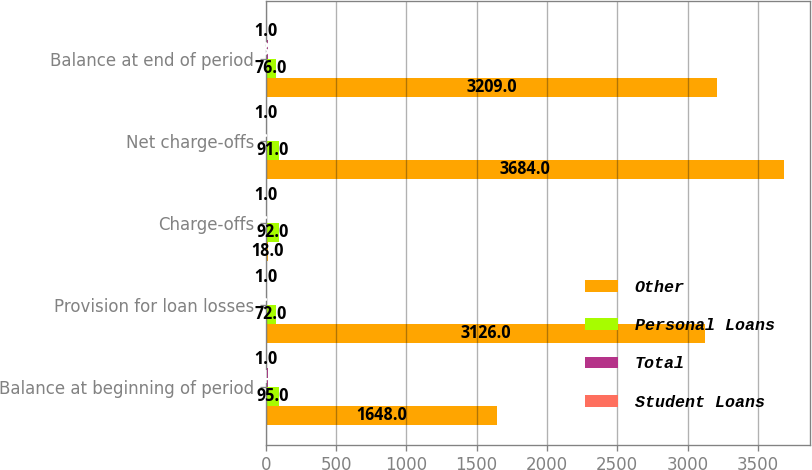<chart> <loc_0><loc_0><loc_500><loc_500><stacked_bar_chart><ecel><fcel>Balance at beginning of period<fcel>Provision for loan losses<fcel>Charge-offs<fcel>Net charge-offs<fcel>Balance at end of period<nl><fcel>Other<fcel>1648<fcel>3126<fcel>18<fcel>3684<fcel>3209<nl><fcel>Personal Loans<fcel>95<fcel>72<fcel>92<fcel>91<fcel>76<nl><fcel>Total<fcel>14<fcel>8<fcel>4<fcel>4<fcel>18<nl><fcel>Student Loans<fcel>1<fcel>1<fcel>1<fcel>1<fcel>1<nl></chart> 